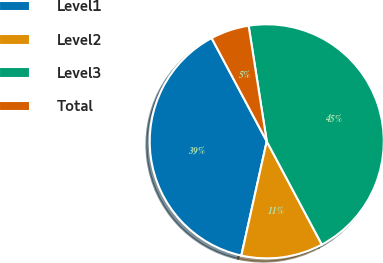Convert chart. <chart><loc_0><loc_0><loc_500><loc_500><pie_chart><fcel>Level1<fcel>Level2<fcel>Level3<fcel>Total<nl><fcel>38.71%<fcel>11.29%<fcel>44.67%<fcel>5.33%<nl></chart> 